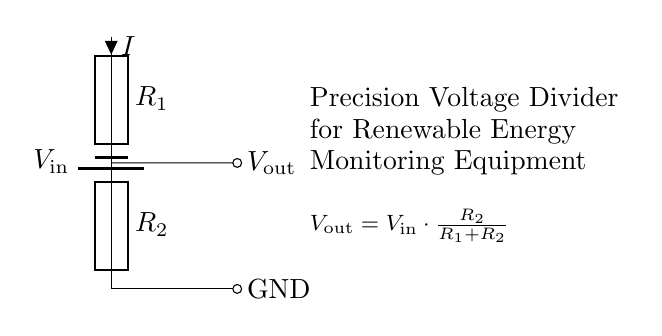What is the input voltage of this circuit? The input voltage, denoted as V_in, is the voltage supplied by the battery. It is not specified in the diagram, so we only recognize it as V_in without a numerical value.
Answer: V_in What are the values of R1 and R2? The circuit diagram labels R1 and R2 as resistors, but it does not provide specific numerical values for them. Thus, we identify them merely as R1 and R2 with no specific resistance values assigned.
Answer: R1 and R2 What type of circuit is this? This circuit is identified as a voltage divider, which is a specific circuit arrangement used to reduce an input voltage to a lower output voltage.
Answer: Voltage divider What is the output voltage equation? The output voltage equation is given in the diagram as V_out = V_in * (R2 / (R1 + R2)), which relates the output voltage to input voltage and the resistance values.
Answer: V_out = V_in * (R2 / (R1 + R2)) Which component is connected to ground? The lower terminal of R2 is connected to ground in the circuit diagram, indicating that it is the reference point (0V) for this circuit.
Answer: R2 How does changing R2 affect V_out? Increasing R2 while keeping R1 constant results in a higher output voltage V_out, while decreasing R2 yields a lower output voltage, demonstrating the dependence of output on the resistor values.
Answer: Increases or decreases output voltage 